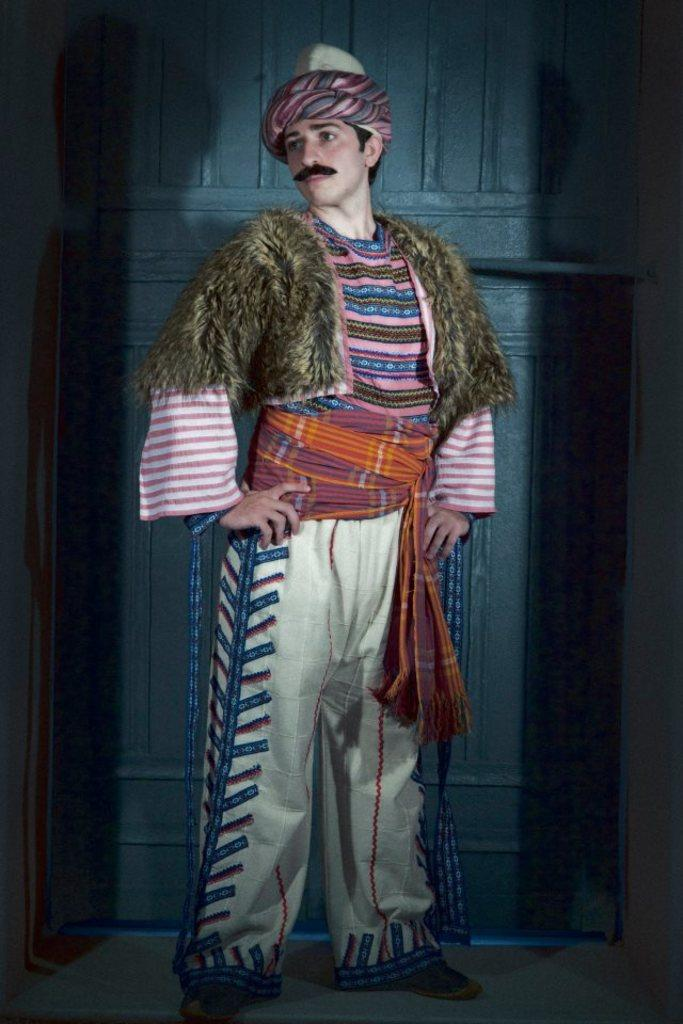What is the main subject of the image? There is a person standing in the center of the image. Can you describe the person's surroundings? There is a door behind the person. What type of cub can be seen playing on the edge of the floor in the image? There is no cub or edge of the floor present in the image; it features a person standing in the center with a door behind them. 